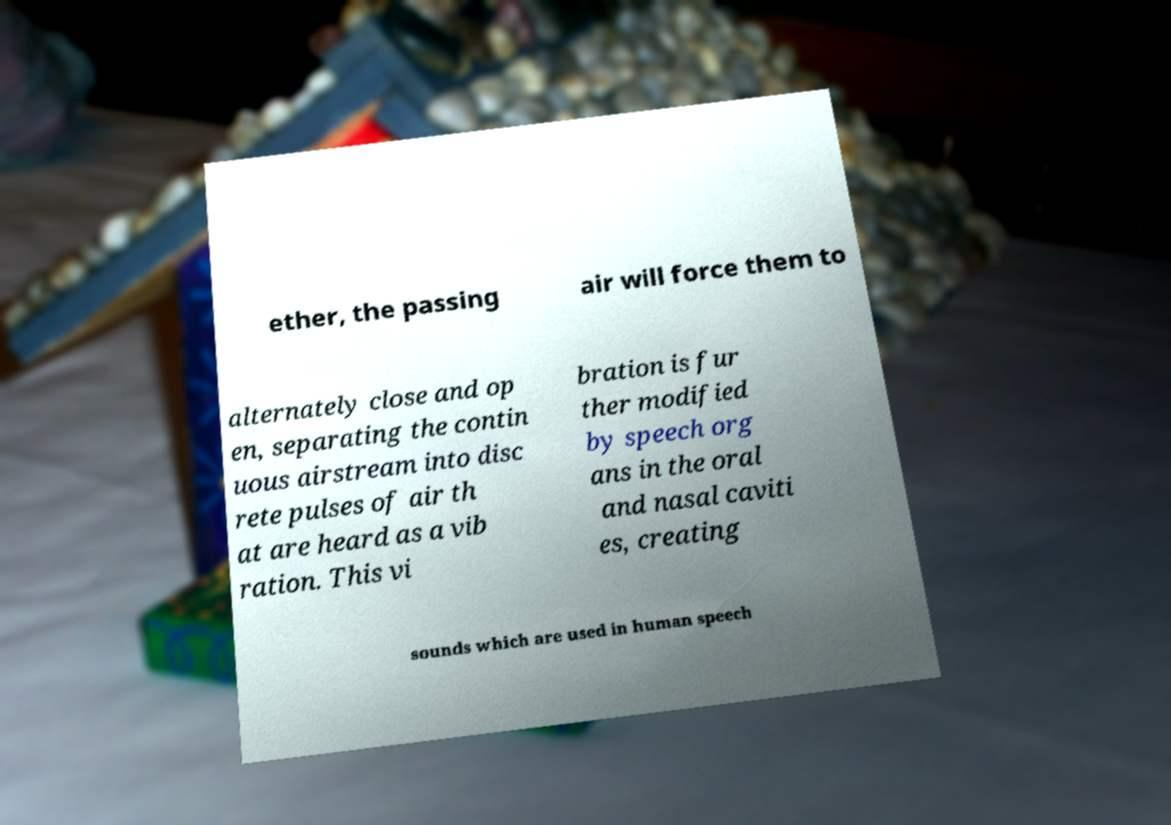For documentation purposes, I need the text within this image transcribed. Could you provide that? ether, the passing air will force them to alternately close and op en, separating the contin uous airstream into disc rete pulses of air th at are heard as a vib ration. This vi bration is fur ther modified by speech org ans in the oral and nasal caviti es, creating sounds which are used in human speech 